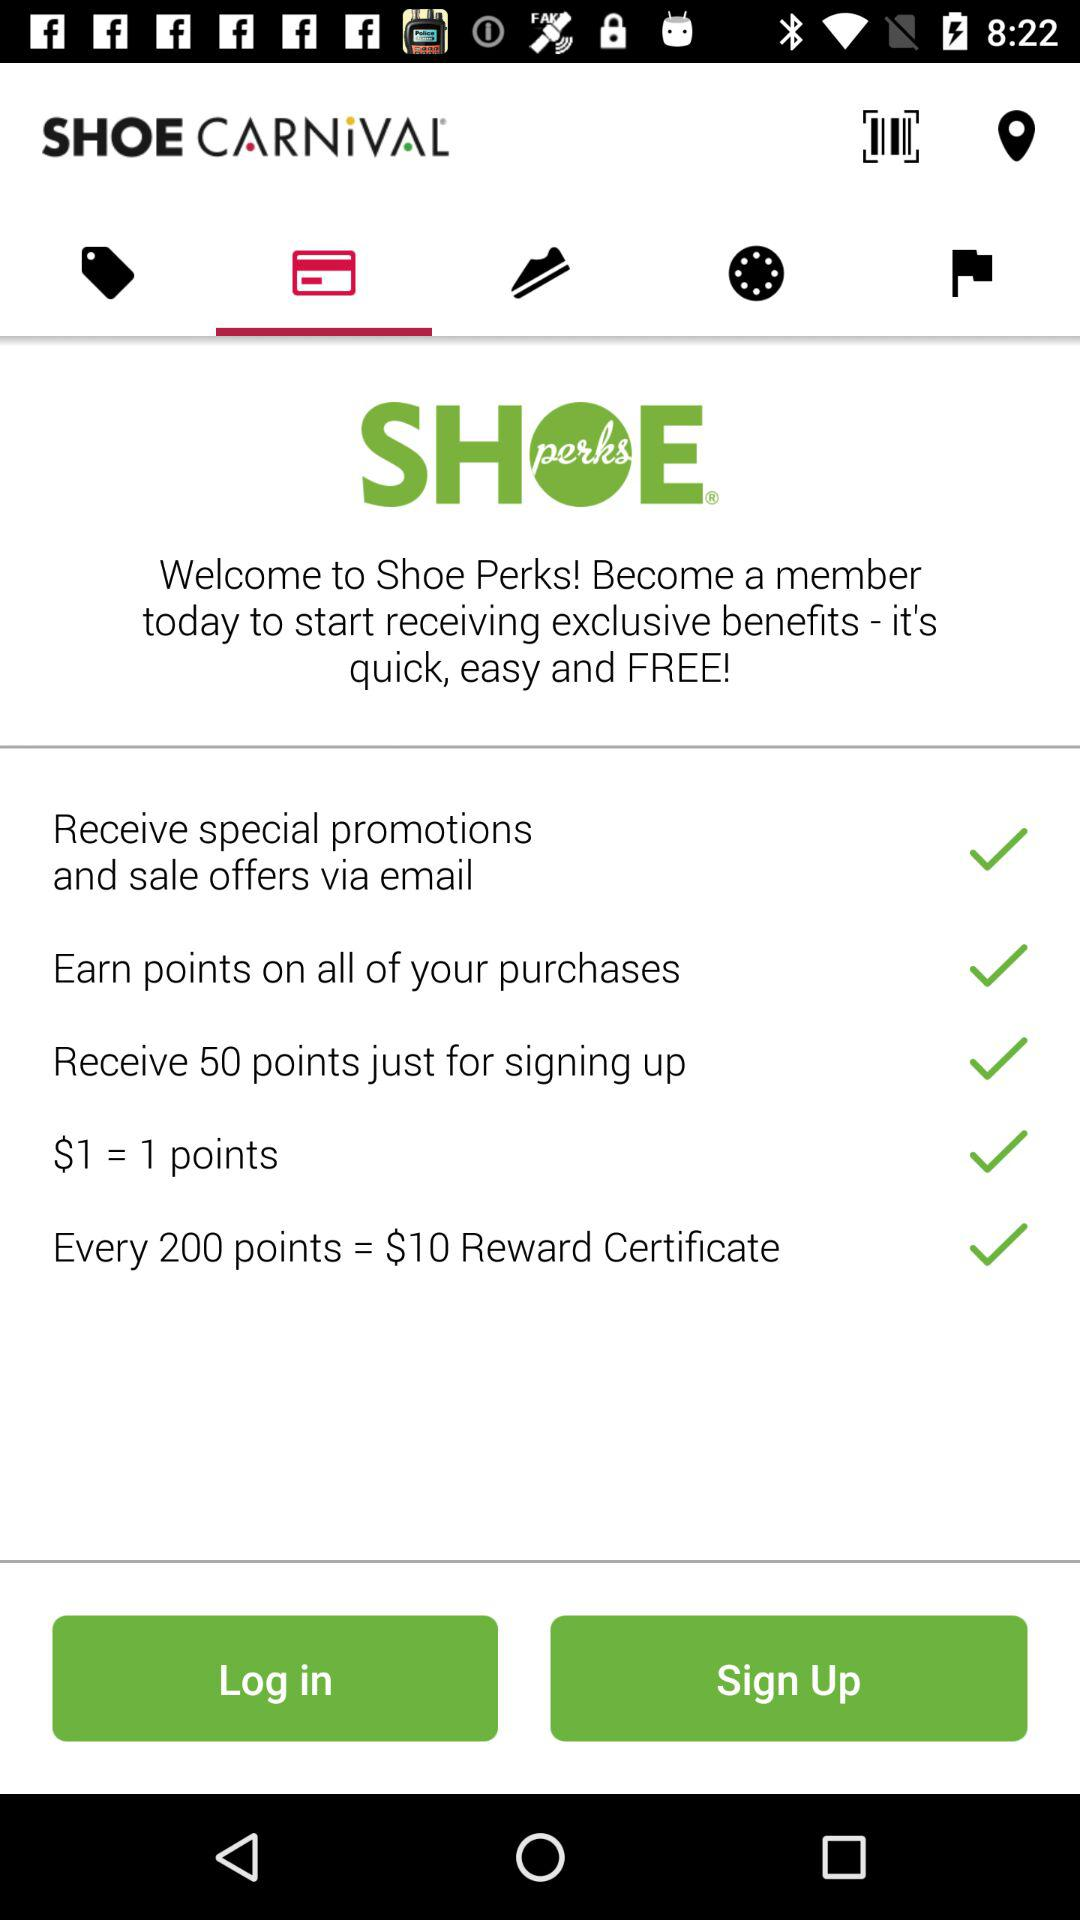What is equal to the $10 reward certificate? The $10 reward certificate is equal to every 200 points. 